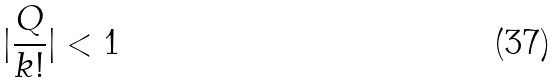Convert formula to latex. <formula><loc_0><loc_0><loc_500><loc_500>| \frac { Q } { k ! } | < 1</formula> 